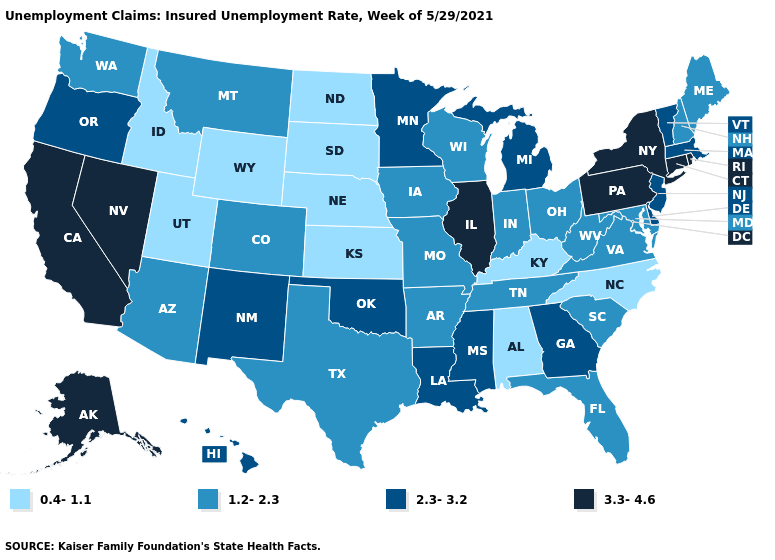What is the lowest value in states that border Nevada?
Keep it brief. 0.4-1.1. What is the value of Illinois?
Write a very short answer. 3.3-4.6. Does Michigan have the highest value in the MidWest?
Write a very short answer. No. What is the lowest value in the USA?
Answer briefly. 0.4-1.1. Name the states that have a value in the range 0.4-1.1?
Concise answer only. Alabama, Idaho, Kansas, Kentucky, Nebraska, North Carolina, North Dakota, South Dakota, Utah, Wyoming. Name the states that have a value in the range 1.2-2.3?
Write a very short answer. Arizona, Arkansas, Colorado, Florida, Indiana, Iowa, Maine, Maryland, Missouri, Montana, New Hampshire, Ohio, South Carolina, Tennessee, Texas, Virginia, Washington, West Virginia, Wisconsin. Does South Carolina have a higher value than Oklahoma?
Quick response, please. No. Name the states that have a value in the range 2.3-3.2?
Quick response, please. Delaware, Georgia, Hawaii, Louisiana, Massachusetts, Michigan, Minnesota, Mississippi, New Jersey, New Mexico, Oklahoma, Oregon, Vermont. Among the states that border Montana , which have the highest value?
Quick response, please. Idaho, North Dakota, South Dakota, Wyoming. What is the value of New Jersey?
Keep it brief. 2.3-3.2. Does the map have missing data?
Give a very brief answer. No. Name the states that have a value in the range 0.4-1.1?
Short answer required. Alabama, Idaho, Kansas, Kentucky, Nebraska, North Carolina, North Dakota, South Dakota, Utah, Wyoming. Name the states that have a value in the range 0.4-1.1?
Be succinct. Alabama, Idaho, Kansas, Kentucky, Nebraska, North Carolina, North Dakota, South Dakota, Utah, Wyoming. What is the value of Michigan?
Write a very short answer. 2.3-3.2. Which states have the lowest value in the USA?
Quick response, please. Alabama, Idaho, Kansas, Kentucky, Nebraska, North Carolina, North Dakota, South Dakota, Utah, Wyoming. 